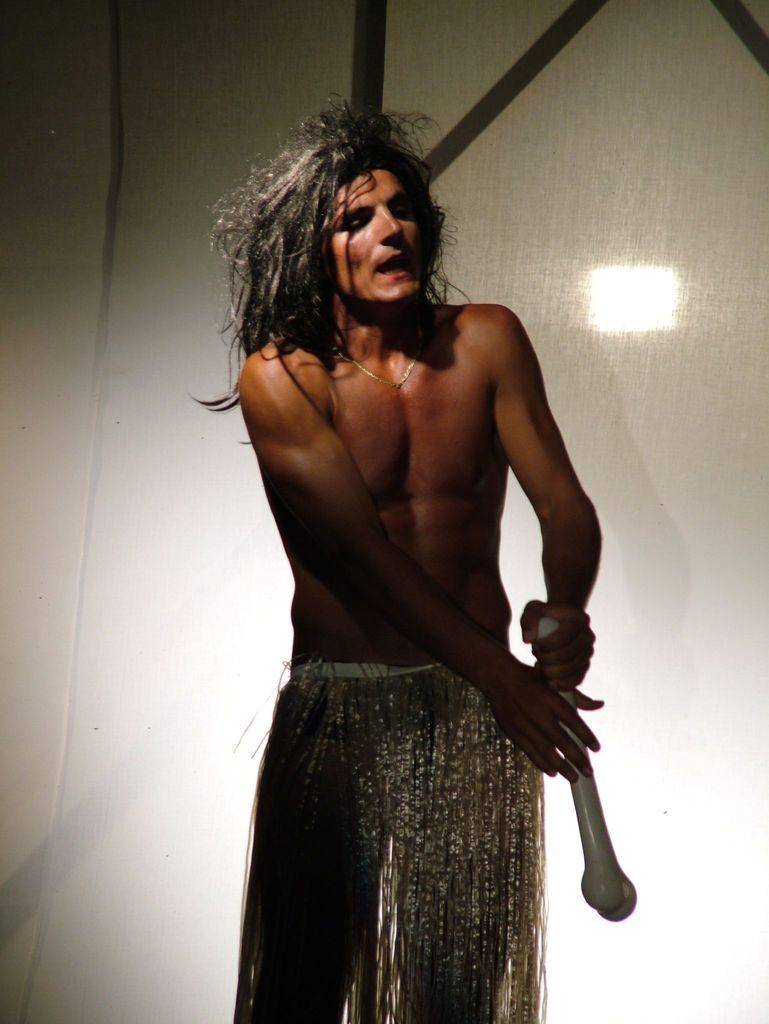Who is present in the image? There is a man in the image. What is the man holding in the image? The man is holding a bone. Can you describe the background of the image? There are objects in the background of the image. What type of bun is the man wearing in the image? There is no bun present in the image; the man is not wearing any headwear. 